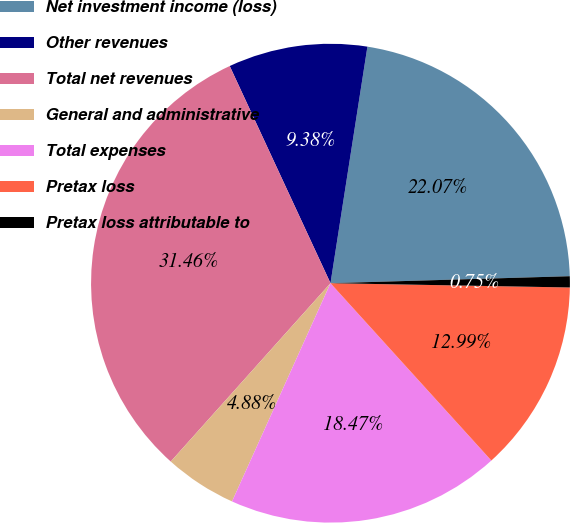Convert chart. <chart><loc_0><loc_0><loc_500><loc_500><pie_chart><fcel>Net investment income (loss)<fcel>Other revenues<fcel>Total net revenues<fcel>General and administrative<fcel>Total expenses<fcel>Pretax loss<fcel>Pretax loss attributable to<nl><fcel>22.07%<fcel>9.38%<fcel>31.46%<fcel>4.88%<fcel>18.47%<fcel>12.99%<fcel>0.75%<nl></chart> 